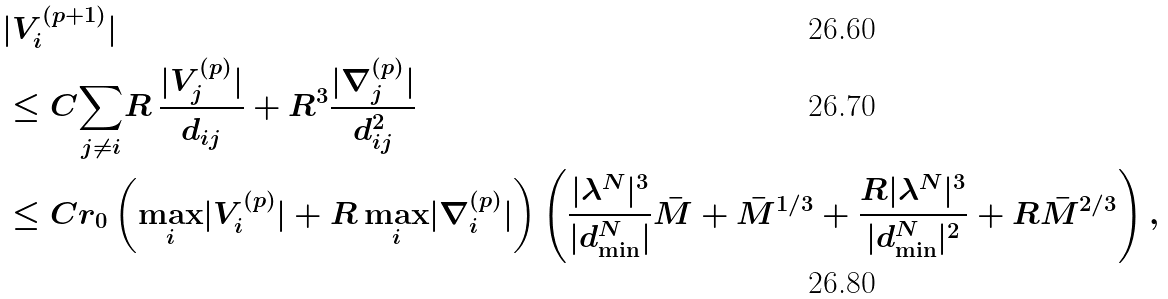<formula> <loc_0><loc_0><loc_500><loc_500>& | V _ { i } ^ { ( p + 1 ) } | \\ & \leq C \underset { j \neq i } { \sum } R \, \frac { | V _ { j } ^ { ( p ) } | } { d _ { i j } } + R ^ { 3 } \frac { | \nabla _ { j } ^ { ( p ) } | } { d _ { i j } ^ { 2 } } \\ & \leq C r _ { 0 } \left ( \underset { i } { \max } | V _ { i } ^ { ( p ) } | + R \, \underset { i } { \max } | \nabla _ { i } ^ { ( p ) } | \right ) \left ( \frac { | \lambda ^ { N } | ^ { 3 } } { | d _ { \min } ^ { N } | } \bar { M } + \bar { M } ^ { 1 / 3 } + \frac { R | \lambda ^ { N } | ^ { 3 } } { | d _ { \min } ^ { N } | ^ { 2 } } + R \bar { M } ^ { 2 / 3 } \right ) ,</formula> 